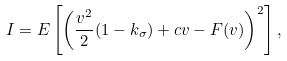<formula> <loc_0><loc_0><loc_500><loc_500>I = E \left [ \left ( \frac { v ^ { 2 } } { 2 } ( 1 - k _ { \sigma } ) + c v - F ( v ) \right ) ^ { 2 } \right ] ,</formula> 